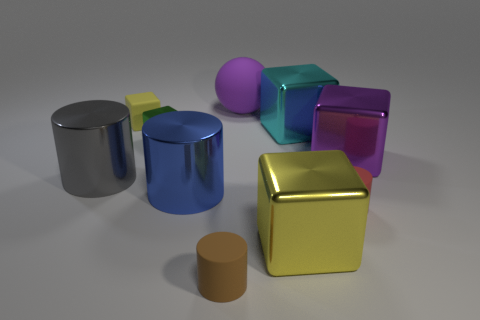How many small objects are red metal objects or green metallic blocks?
Your answer should be compact. 1. Are there the same number of small green metal cubes in front of the small green thing and shiny objects left of the blue metallic thing?
Your answer should be very brief. No. What number of other things are the same color as the matte ball?
Give a very brief answer. 1. There is a rubber ball; does it have the same color as the big cube on the right side of the tiny red cylinder?
Make the answer very short. Yes. What number of cyan objects are either cylinders or small metal things?
Make the answer very short. 0. Are there the same number of tiny brown matte cylinders to the right of the purple metal block and purple cylinders?
Make the answer very short. Yes. Are there any other things that are the same size as the yellow matte object?
Offer a terse response. Yes. The tiny metallic object that is the same shape as the large yellow object is what color?
Your response must be concise. Green. What number of small rubber objects are the same shape as the large gray object?
Provide a succinct answer. 2. What material is the other thing that is the same color as the large rubber object?
Provide a short and direct response. Metal. 